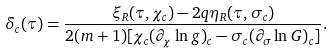<formula> <loc_0><loc_0><loc_500><loc_500>\delta _ { c } ( \tau ) = \frac { \xi _ { R } ( \tau , \chi _ { c } ) - 2 q \eta _ { R } ( \tau , \sigma _ { c } ) } { 2 ( m + 1 ) [ \chi _ { c } ( \partial _ { \chi } \ln g ) _ { c } - \sigma _ { c } ( \partial _ { \sigma } \ln G ) _ { c } ] } .</formula> 